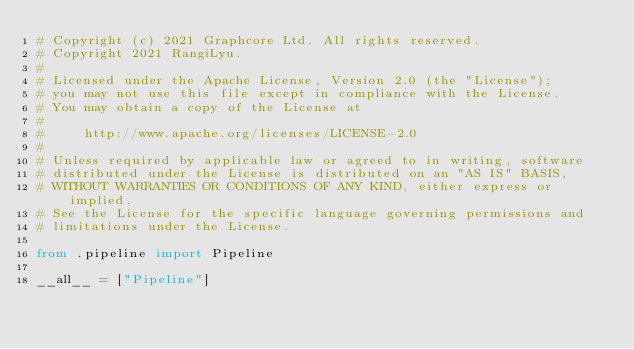<code> <loc_0><loc_0><loc_500><loc_500><_Python_># Copyright (c) 2021 Graphcore Ltd. All rights reserved.
# Copyright 2021 RangiLyu.
#
# Licensed under the Apache License, Version 2.0 (the "License");
# you may not use this file except in compliance with the License.
# You may obtain a copy of the License at
#
#     http://www.apache.org/licenses/LICENSE-2.0
#
# Unless required by applicable law or agreed to in writing, software
# distributed under the License is distributed on an "AS IS" BASIS,
# WITHOUT WARRANTIES OR CONDITIONS OF ANY KIND, either express or implied.
# See the License for the specific language governing permissions and
# limitations under the License.

from .pipeline import Pipeline

__all__ = ["Pipeline"]
</code> 